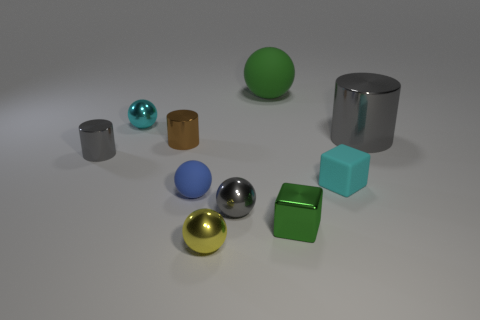The block that is the same material as the small yellow sphere is what size? The small yellow sphere in the image appears to have the same metallic sheen as the small silver cylinder, suggesting they are made of similar materials. In terms of size, both the sphere and the cylinder are small compared to the other objects present. 